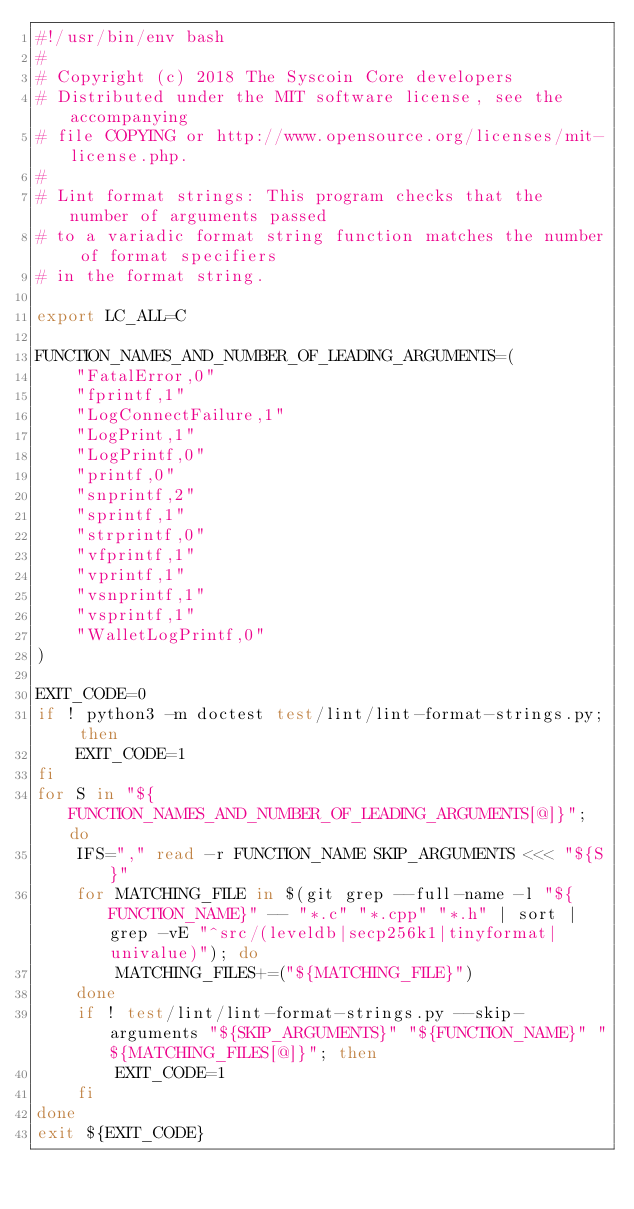Convert code to text. <code><loc_0><loc_0><loc_500><loc_500><_Bash_>#!/usr/bin/env bash
#
# Copyright (c) 2018 The Syscoin Core developers
# Distributed under the MIT software license, see the accompanying
# file COPYING or http://www.opensource.org/licenses/mit-license.php.
#
# Lint format strings: This program checks that the number of arguments passed
# to a variadic format string function matches the number of format specifiers
# in the format string.

export LC_ALL=C

FUNCTION_NAMES_AND_NUMBER_OF_LEADING_ARGUMENTS=(
    "FatalError,0"
    "fprintf,1"
    "LogConnectFailure,1"
    "LogPrint,1"
    "LogPrintf,0"
    "printf,0"
    "snprintf,2"
    "sprintf,1"
    "strprintf,0"
    "vfprintf,1"
    "vprintf,1"
    "vsnprintf,1"
    "vsprintf,1"
    "WalletLogPrintf,0"
)

EXIT_CODE=0
if ! python3 -m doctest test/lint/lint-format-strings.py; then
    EXIT_CODE=1
fi
for S in "${FUNCTION_NAMES_AND_NUMBER_OF_LEADING_ARGUMENTS[@]}"; do
    IFS="," read -r FUNCTION_NAME SKIP_ARGUMENTS <<< "${S}"
    for MATCHING_FILE in $(git grep --full-name -l "${FUNCTION_NAME}" -- "*.c" "*.cpp" "*.h" | sort | grep -vE "^src/(leveldb|secp256k1|tinyformat|univalue)"); do
        MATCHING_FILES+=("${MATCHING_FILE}")
    done
    if ! test/lint/lint-format-strings.py --skip-arguments "${SKIP_ARGUMENTS}" "${FUNCTION_NAME}" "${MATCHING_FILES[@]}"; then
        EXIT_CODE=1
    fi
done
exit ${EXIT_CODE}
</code> 